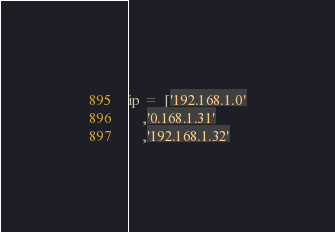<code> <loc_0><loc_0><loc_500><loc_500><_Python_>ip =  ['192.168.1.0'
    ,'0.168.1.31'
    ,'192.168.1.32'</code> 